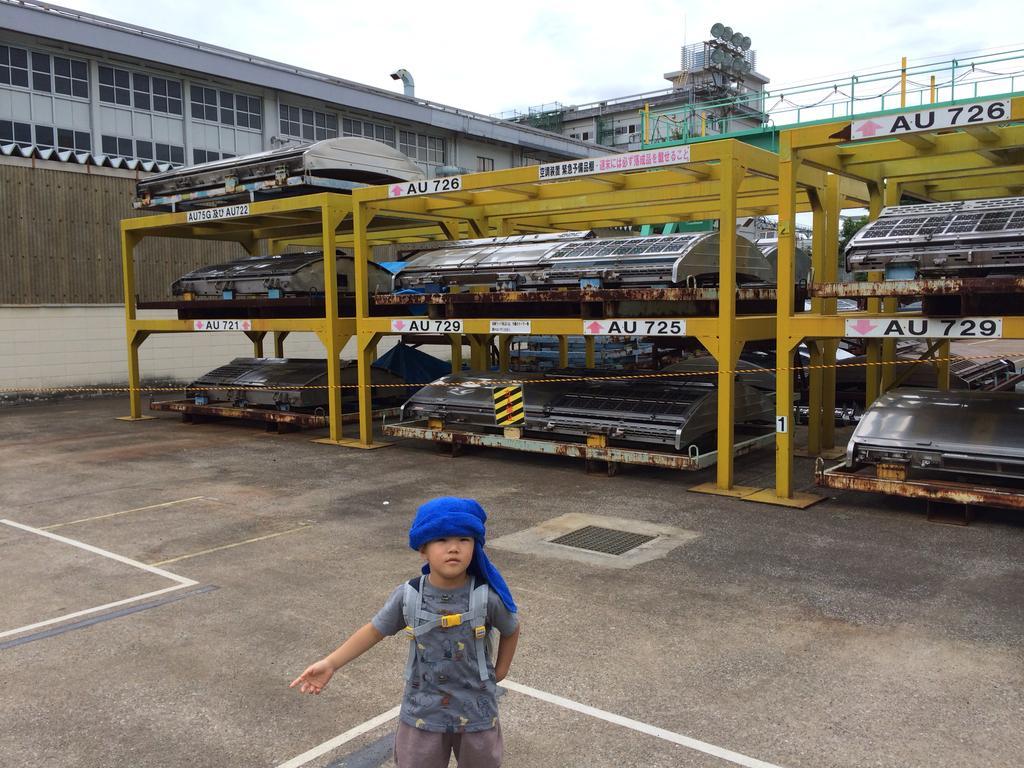Describe this image in one or two sentences. In this image we can see some iron objects and some stickers are attached to them. In the background of the image there is a building, antenna, railing and other objects. At the bottom of the image there is a person and the road. 